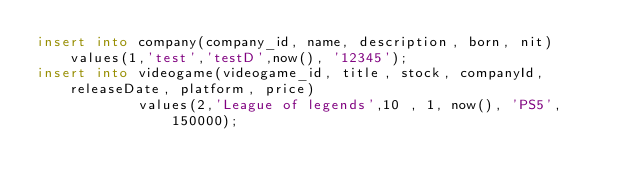Convert code to text. <code><loc_0><loc_0><loc_500><loc_500><_SQL_>insert into company(company_id, name, description, born, nit) values(1,'test','testD',now(), '12345');
insert into videogame(videogame_id, title, stock, companyId, releaseDate, platform, price)
            values(2,'League of legends',10 , 1, now(), 'PS5', 150000);</code> 